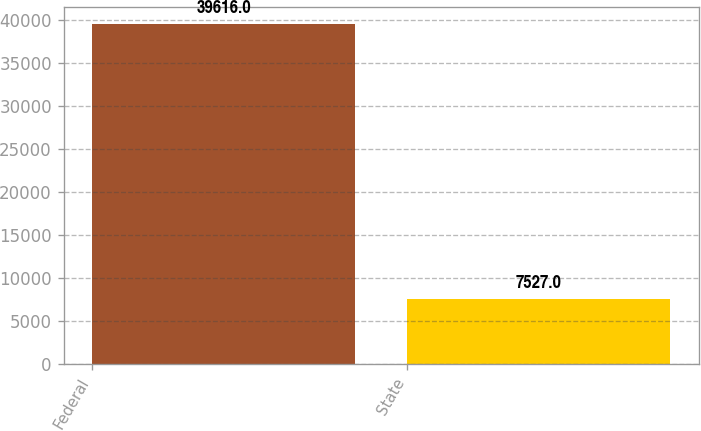Convert chart. <chart><loc_0><loc_0><loc_500><loc_500><bar_chart><fcel>Federal<fcel>State<nl><fcel>39616<fcel>7527<nl></chart> 